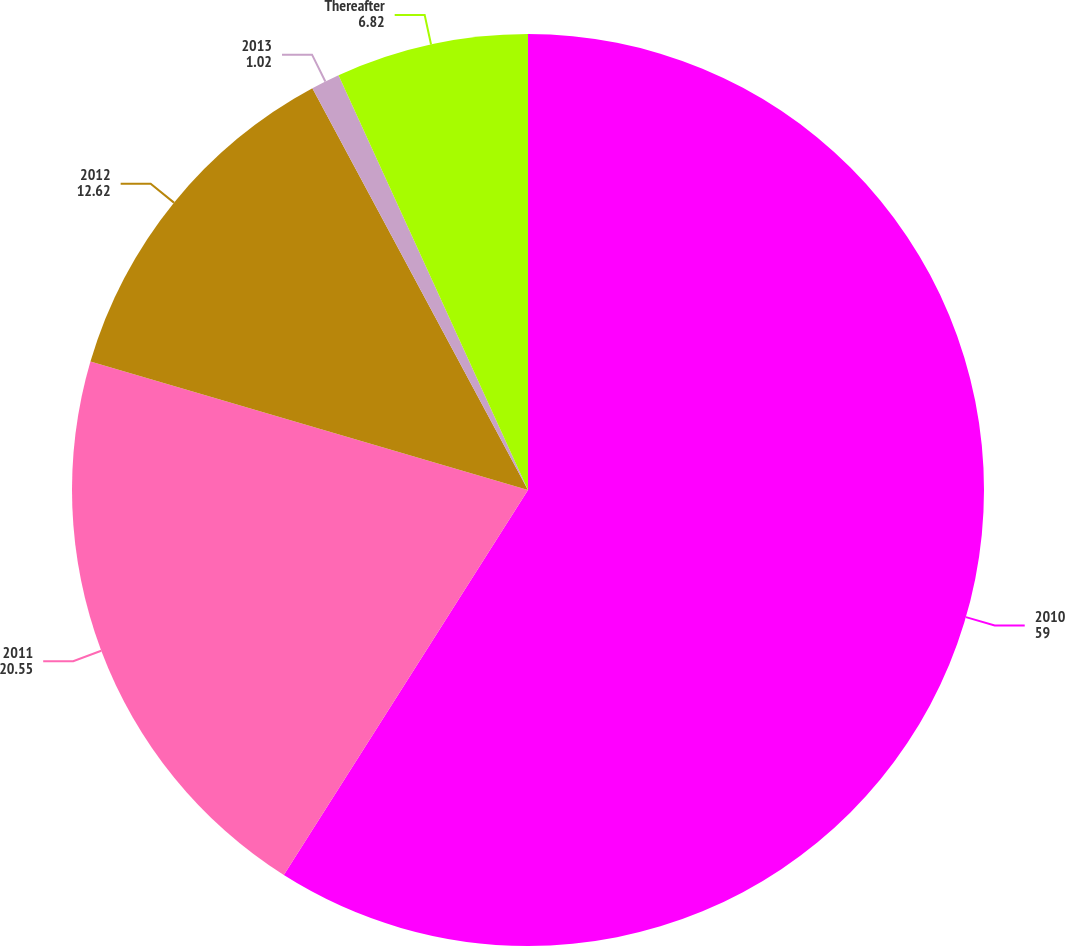<chart> <loc_0><loc_0><loc_500><loc_500><pie_chart><fcel>2010<fcel>2011<fcel>2012<fcel>2013<fcel>Thereafter<nl><fcel>59.0%<fcel>20.55%<fcel>12.62%<fcel>1.02%<fcel>6.82%<nl></chart> 